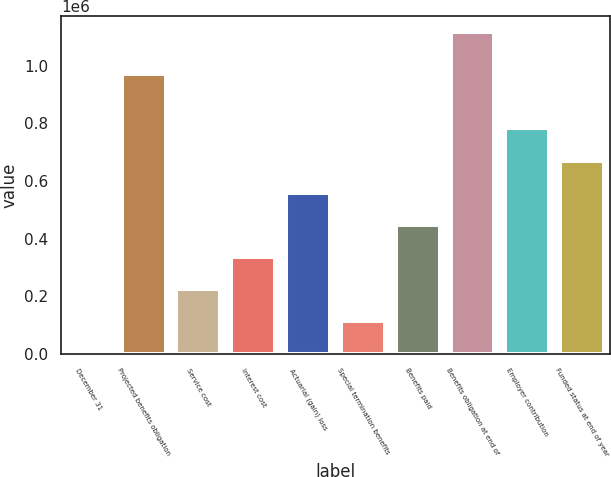<chart> <loc_0><loc_0><loc_500><loc_500><bar_chart><fcel>December 31<fcel>Projected benefits obligation<fcel>Service cost<fcel>Interest cost<fcel>Actuarial (gain) loss<fcel>Special termination benefits<fcel>Benefits paid<fcel>Benefits obligation at end of<fcel>Employer contribution<fcel>Funded status at end of year<nl><fcel>2005<fcel>972073<fcel>224847<fcel>336268<fcel>559110<fcel>113426<fcel>447689<fcel>1.11621e+06<fcel>781951<fcel>670530<nl></chart> 